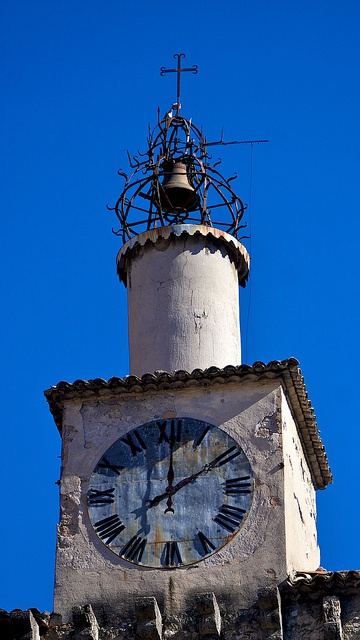Describe the objects in this image and their specific colors. I can see a clock in blue, gray, black, and navy tones in this image. 